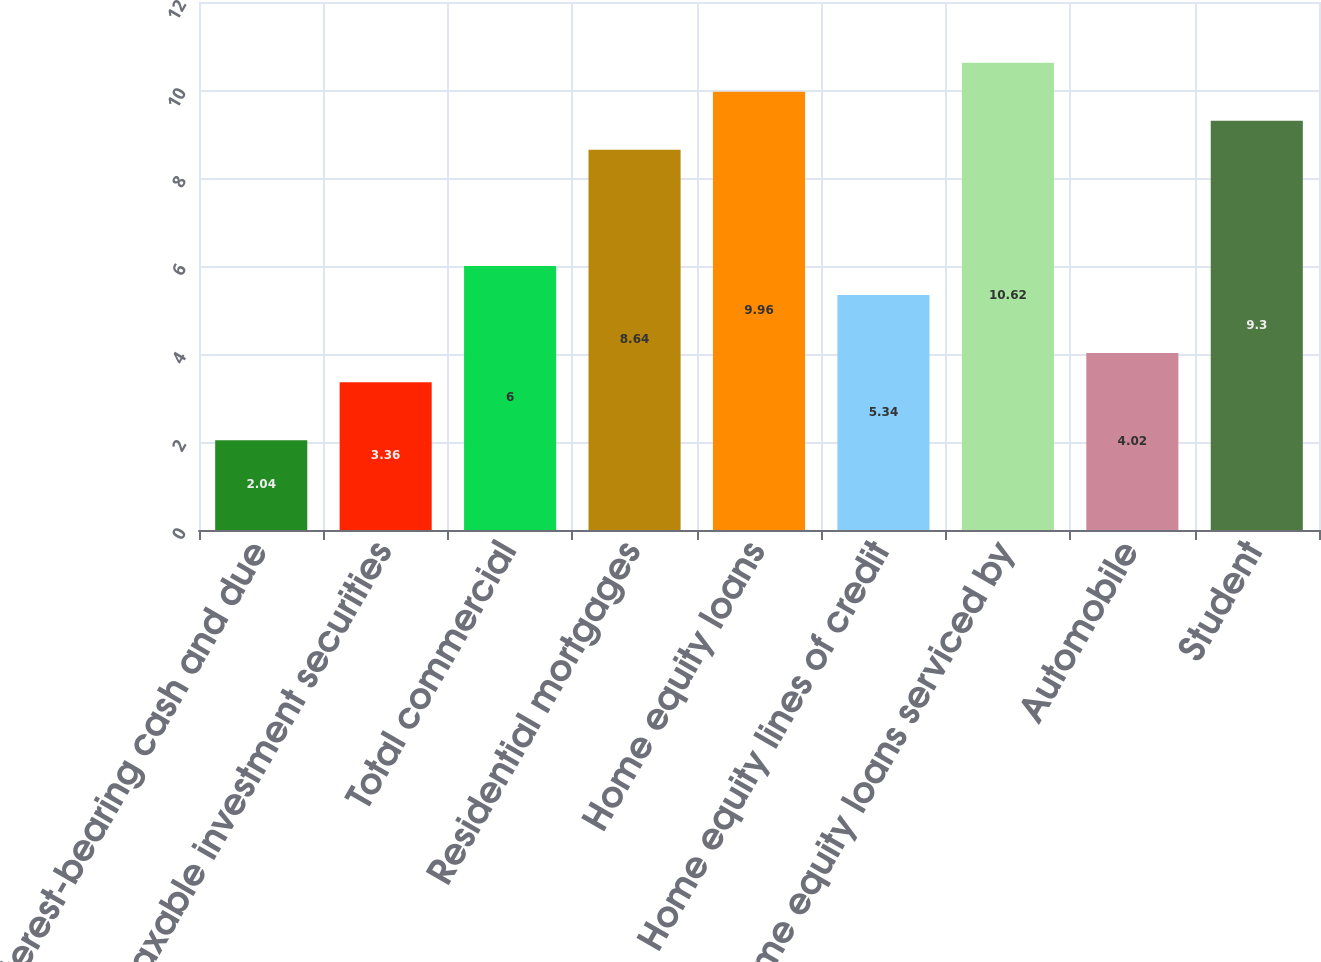Convert chart to OTSL. <chart><loc_0><loc_0><loc_500><loc_500><bar_chart><fcel>Interest-bearing cash and due<fcel>Taxable investment securities<fcel>Total commercial<fcel>Residential mortgages<fcel>Home equity loans<fcel>Home equity lines of credit<fcel>Home equity loans serviced by<fcel>Automobile<fcel>Student<nl><fcel>2.04<fcel>3.36<fcel>6<fcel>8.64<fcel>9.96<fcel>5.34<fcel>10.62<fcel>4.02<fcel>9.3<nl></chart> 